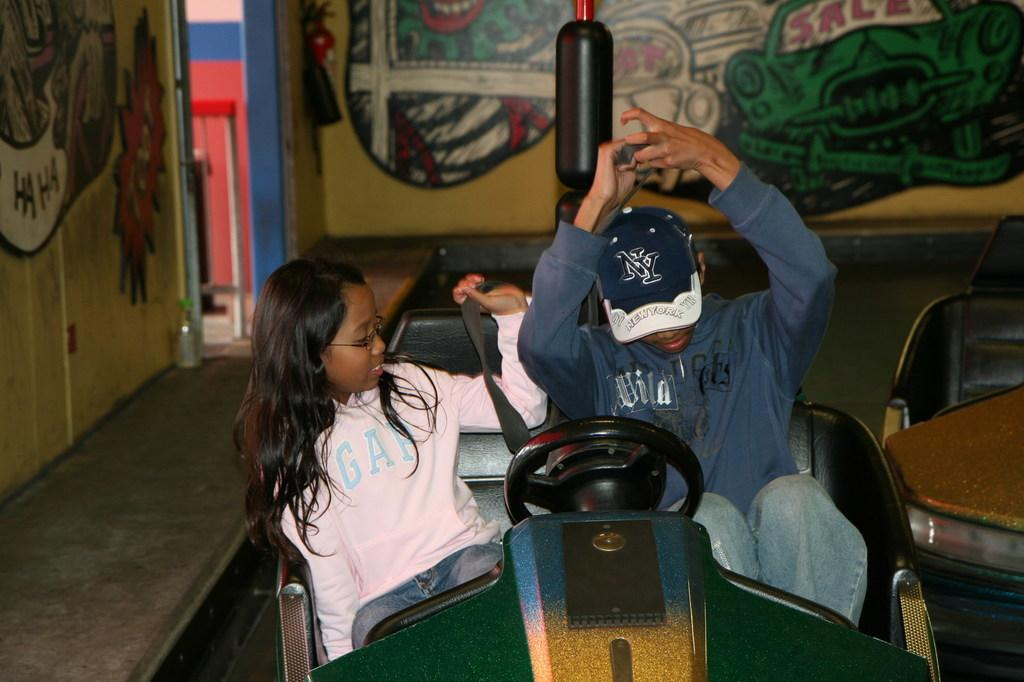<image>
Write a terse but informative summary of the picture. a person that is wearing a hat with the city New York on it 